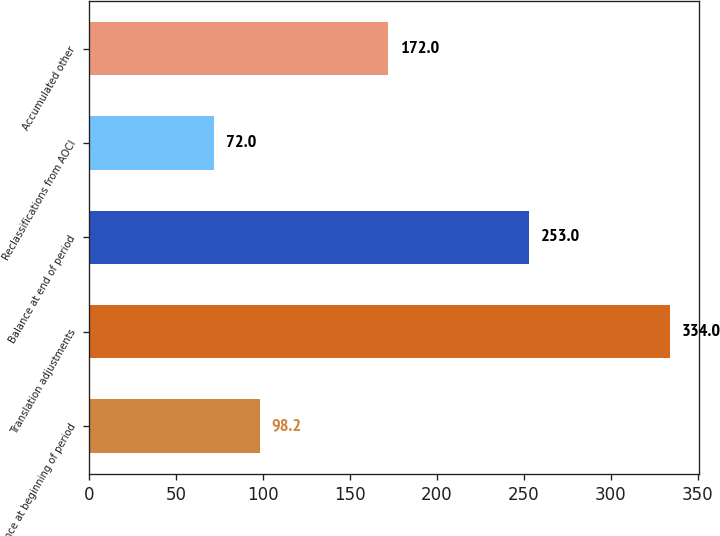<chart> <loc_0><loc_0><loc_500><loc_500><bar_chart><fcel>Balance at beginning of period<fcel>Translation adjustments<fcel>Balance at end of period<fcel>Reclassifications from AOCI<fcel>Accumulated other<nl><fcel>98.2<fcel>334<fcel>253<fcel>72<fcel>172<nl></chart> 